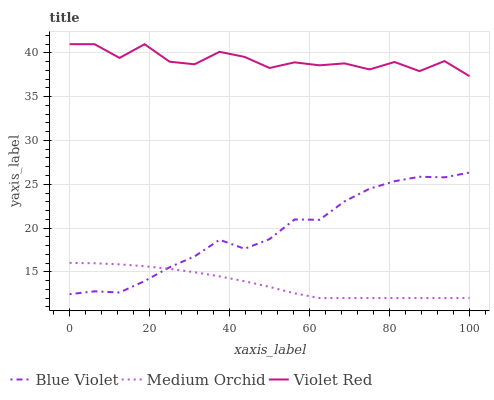Does Blue Violet have the minimum area under the curve?
Answer yes or no. No. Does Blue Violet have the maximum area under the curve?
Answer yes or no. No. Is Blue Violet the smoothest?
Answer yes or no. No. Is Blue Violet the roughest?
Answer yes or no. No. Does Blue Violet have the lowest value?
Answer yes or no. No. Does Blue Violet have the highest value?
Answer yes or no. No. Is Blue Violet less than Violet Red?
Answer yes or no. Yes. Is Violet Red greater than Blue Violet?
Answer yes or no. Yes. Does Blue Violet intersect Violet Red?
Answer yes or no. No. 